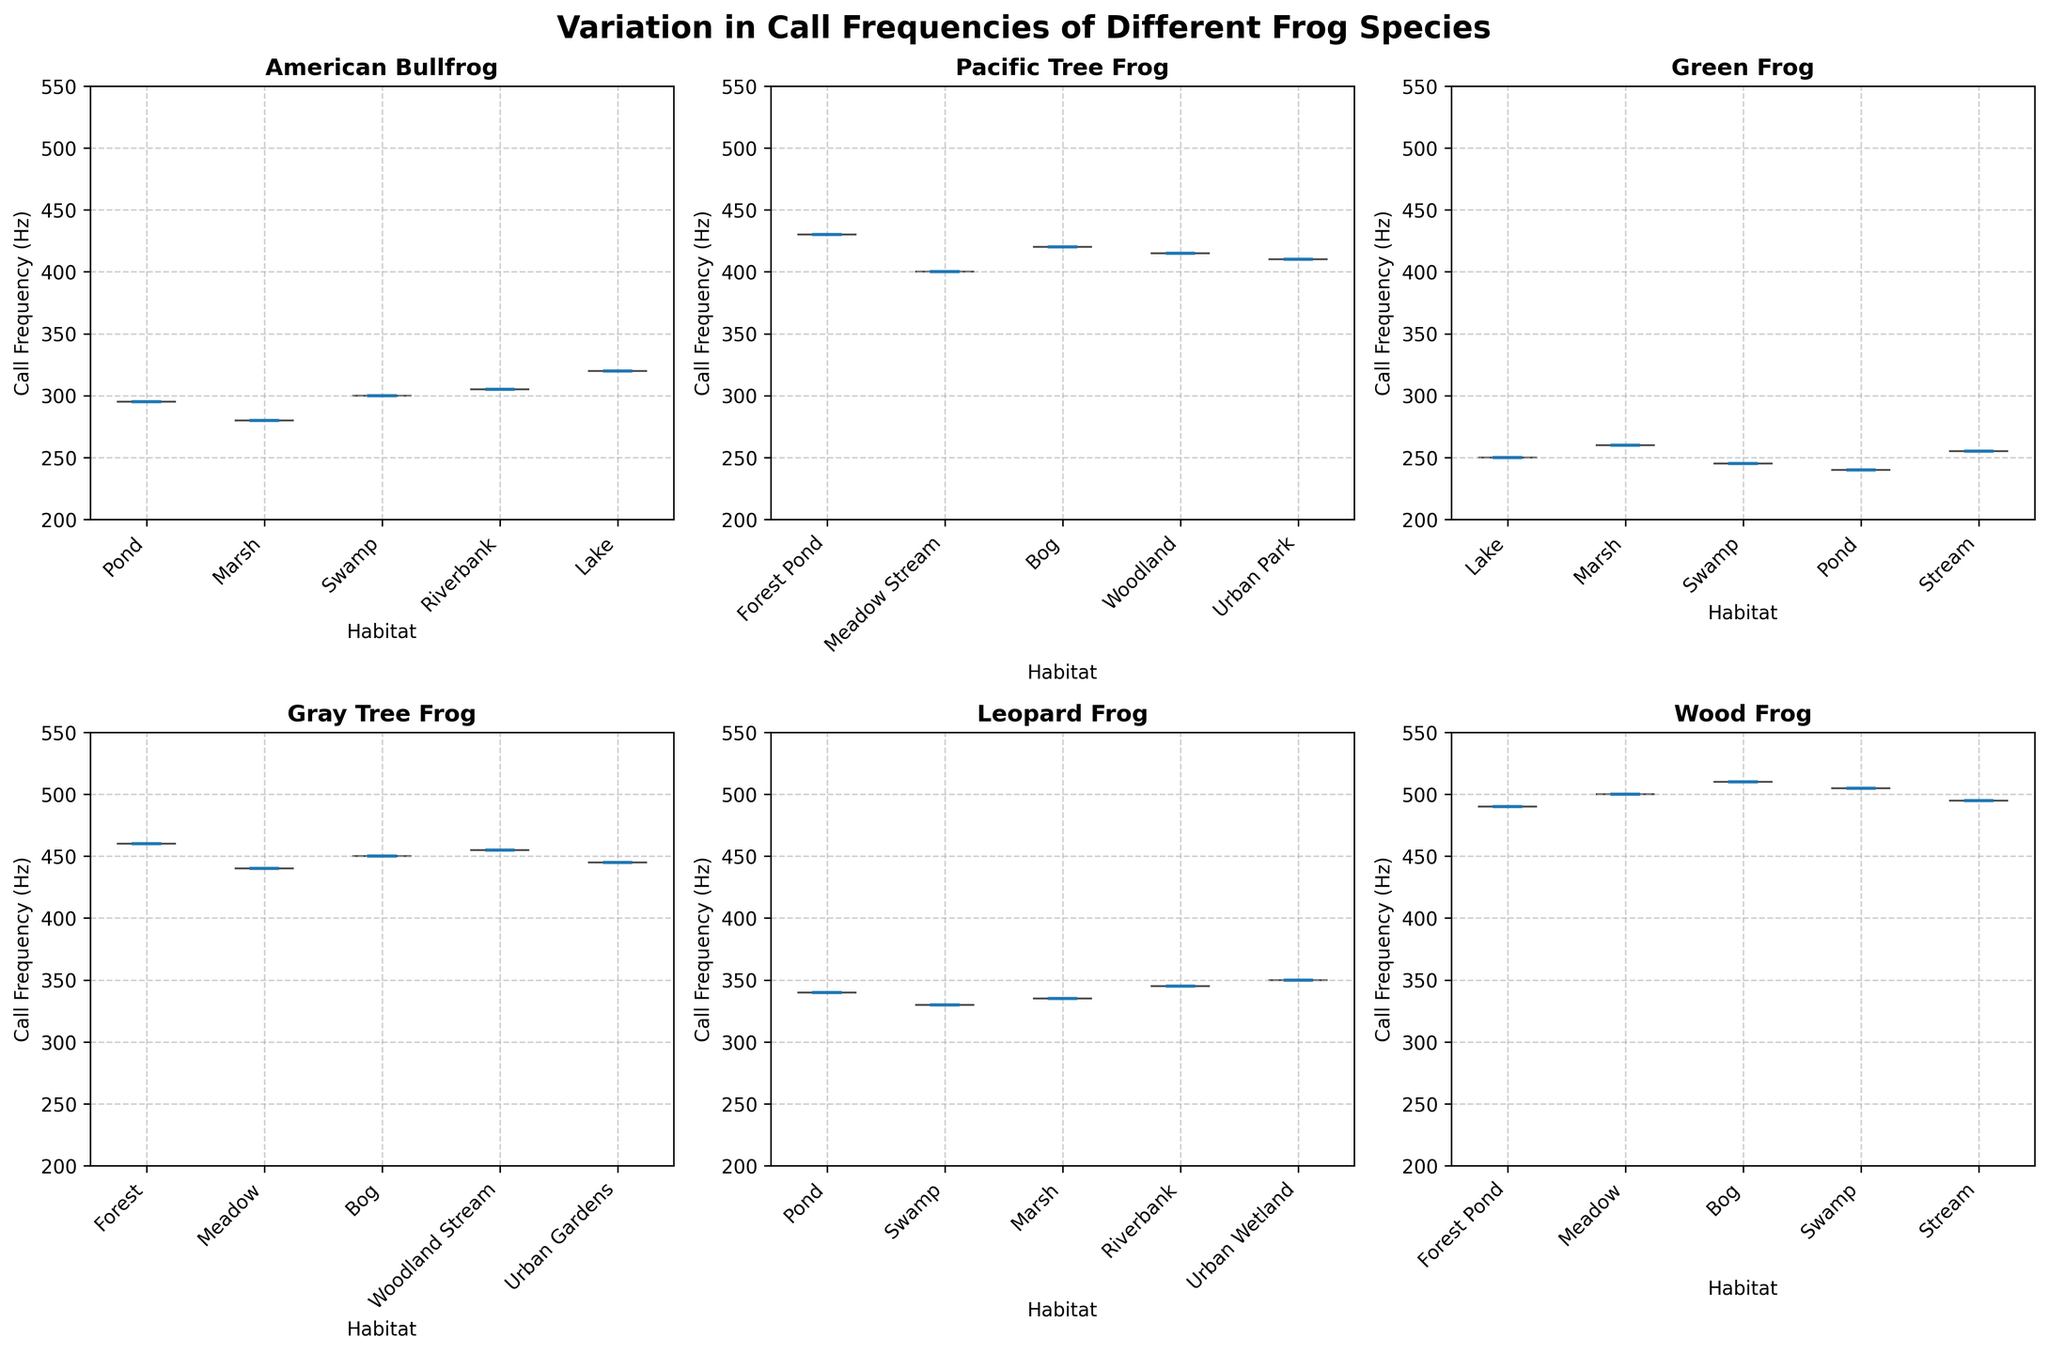Which species has the highest median call frequency? Look at the median values indicated on the violin plots. The Wood Frog has the highest median call frequency, located around 500 Hz.
Answer: Wood Frog Which habitat has the widest variation in call frequency for the Pacific Tree Frog? Examine the width of the violin plots for each habitat. The Bog habitat has the widest spread for the Pacific Tree Frog.
Answer: Bog How does the mean call frequency of the Green Frog in Swamp compare to that of the Gray Tree Frog in the same habitat? Look at the mean values shown on the violin plots. The mean call frequency for the Green Frog in Swamp is around 255 Hz, while for the Gray Tree Frog it's around 460 Hz. Green Frog's mean is significantly lower than Gray Tree Frog's.
Answer: Green Frog's mean is lower Which species shows the least variation in call frequencies across its habitats? Identify the species with the narrowest violin plots across its subplots. The Green Frog shows consistently narrow plots, indicating the least variation.
Answer: Green Frog What is the median call frequency for the American Bullfrog in the Pond habitat? Look at the middle line in the violin plot for the Pond habitat under the American Bullfrog subplot. The median call frequency is around 300 Hz.
Answer: 300 Hz Compare the call frequency range of the Leopard Frog in Pond and Urban Wetland habitats. Which habitat has a higher frequency range? Observe the span of the violin plots from the lowest to highest point in the Pond and Urban Wetland habitats for the Leopard Frog. The Urban Wetland has a higher frequency range.
Answer: Urban Wetland What is the average call frequency difference between the highest median species and the lowest median species? Identify the species with the highest median (Wood Frog), and the lowest median (Green Frog). The Wood Frog median is around 500 Hz, and the Green Frog median is around 250 Hz, giving us 500 - 250.
Answer: 250 Hz Which species has the highest maximum call frequency observed? Check for the species with the highest peak in any of the plots. The Gray Tree Frog and the Pacific Tree Frog both peak around 460-465 Hz, with the highest peak slightly over 465 Hz for the Gray Tree Frog.
Answer: Gray Tree Frog Compare the mean call frequencies of the Pacific Tree Frog in the Woodland and Urban Park habitats. Which is higher? Look at the mean value indicators in the Woodland and Urban Park violin plots under Pacific Tree Frog. Urban Park has a mean around 415 Hz compared to Woodland's 410 Hz.
Answer: Urban Park Is there any species exhibiting a mean call frequency below 240 Hz in any habitat? Check the lowest means in each subplot. None of the violin plots show mean call frequencies below 240 Hz.
Answer: No 